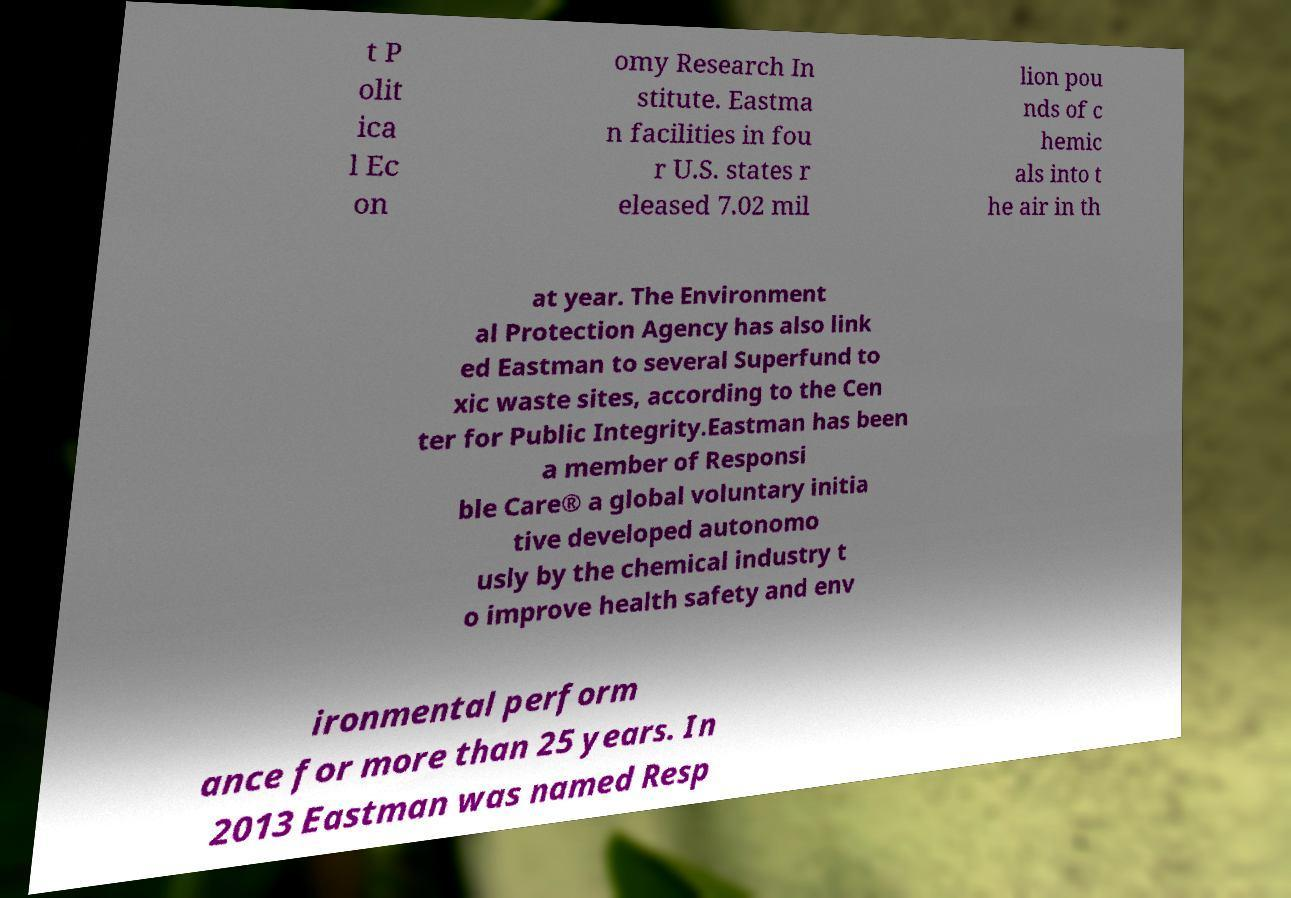There's text embedded in this image that I need extracted. Can you transcribe it verbatim? t P olit ica l Ec on omy Research In stitute. Eastma n facilities in fou r U.S. states r eleased 7.02 mil lion pou nds of c hemic als into t he air in th at year. The Environment al Protection Agency has also link ed Eastman to several Superfund to xic waste sites, according to the Cen ter for Public Integrity.Eastman has been a member of Responsi ble Care® a global voluntary initia tive developed autonomo usly by the chemical industry t o improve health safety and env ironmental perform ance for more than 25 years. In 2013 Eastman was named Resp 